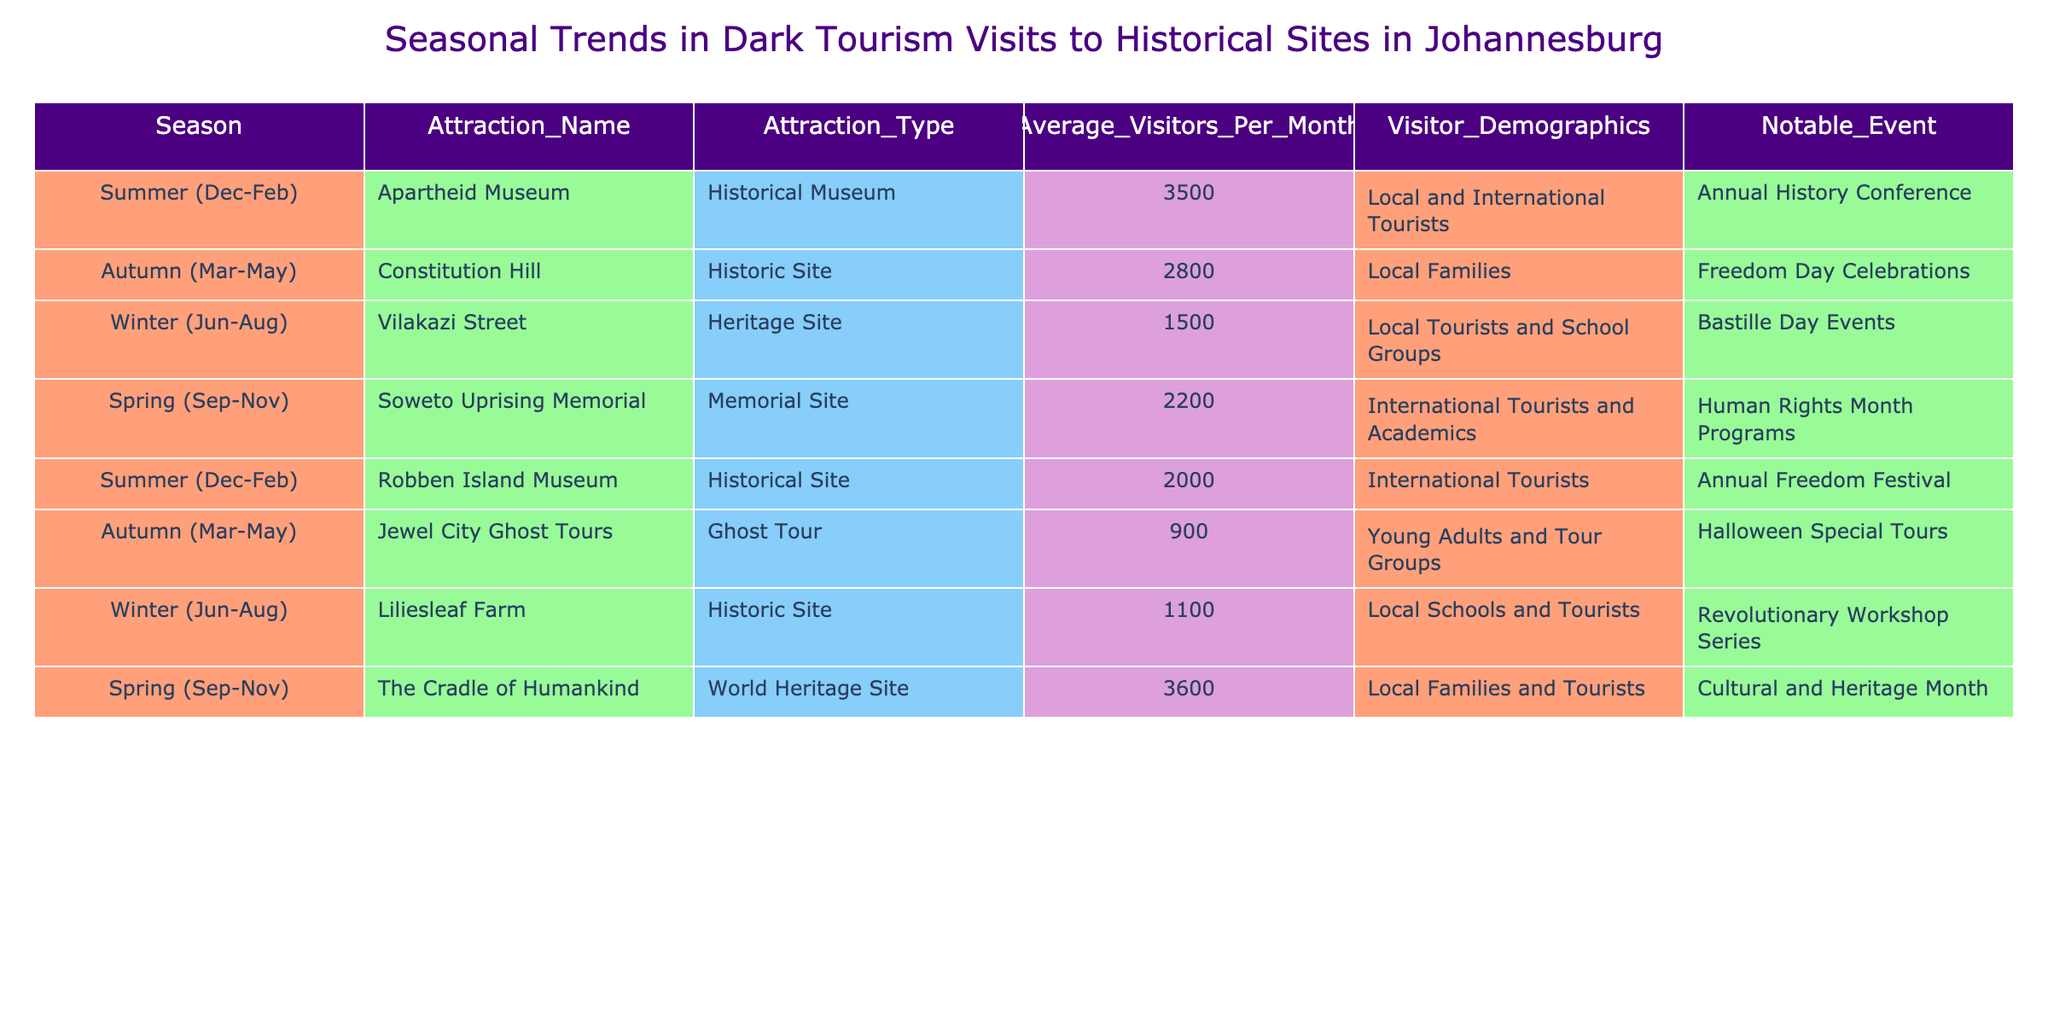What is the most visited attraction during the summer season? The summer season is focused on visitors to the Apartheid Museum, which has an average of 3500 visitors per month, making it the highest among all attractions during summer.
Answer: Apartheid Museum Which attraction had the fewest average monthly visitors in winter? In winter, Vilakazi Street had the fewest average monthly visitors with 1500, while Liliesleaf Farm had 1100; however, it's the most compared to them in that season.
Answer: Vilakazi Street What is the total average number of visitors across all attractions in autumn? To find the total, we add the average visitors for the attractions in autumn: Constitution Hill (2800) + Jewel City Ghost Tours (900) = 3700 total average visitors in autumn.
Answer: 3700 Does the Soweto Uprising Memorial attract more visitors than Liliesleaf Farm in spring? Yes, the Soweto Uprising Memorial has an average of 2200 visitors, which is more than the 1100 average visitors Liliesleaf Farm receives in winter.
Answer: Yes Which season has the highest average visitors overall when all attractions are considered? We can look at the sum of averages for each season: Summer (3500 + 2000) = 5500, Autumn (2800 + 900) = 3700, Winter (1500 + 1100) = 2600, Spring (2200 + 3600) = 5800; therefore, spring has the highest average overall.
Answer: Spring How many more visitors does the Cradle of Humankind get than the Apartheid Museum, on average, during their peak seasons? The Cradle of Humankind receives 3600 visitors in spring, while the Apartheid Museum gets 3500 during summer. The difference is 3600 - 3500 = 100 more visitors for the Cradle of Humankind.
Answer: 100 Is the notable event for the Robben Island Museum a local or international event? The notable event for the Robben Island Museum is the Annual Freedom Festival, which tends to attract international tourists, indicating that it has an international focus.
Answer: International Between winter and spring, which season has the highest total average visitors, and by how much? In winter, the total average visitors (1500 + 1100) is 2600. In spring, the total (2200 + 3600) is 5800. Spring has 5800 - 2600 = 3200 more visitors than winter.
Answer: Spring has 3200 more visitors 